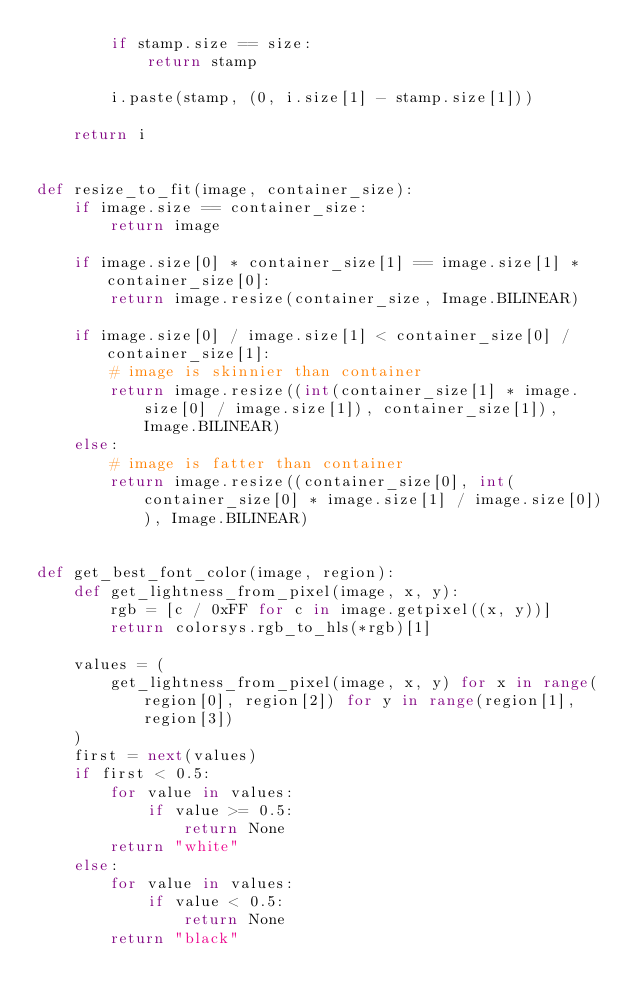Convert code to text. <code><loc_0><loc_0><loc_500><loc_500><_Python_>        if stamp.size == size:
            return stamp

        i.paste(stamp, (0, i.size[1] - stamp.size[1]))

    return i


def resize_to_fit(image, container_size):
    if image.size == container_size:
        return image

    if image.size[0] * container_size[1] == image.size[1] * container_size[0]:
        return image.resize(container_size, Image.BILINEAR)

    if image.size[0] / image.size[1] < container_size[0] / container_size[1]:
        # image is skinnier than container
        return image.resize((int(container_size[1] * image.size[0] / image.size[1]), container_size[1]), Image.BILINEAR)
    else:
        # image is fatter than container
        return image.resize((container_size[0], int(container_size[0] * image.size[1] / image.size[0])), Image.BILINEAR)


def get_best_font_color(image, region):
    def get_lightness_from_pixel(image, x, y):
        rgb = [c / 0xFF for c in image.getpixel((x, y))]
        return colorsys.rgb_to_hls(*rgb)[1]

    values = (
        get_lightness_from_pixel(image, x, y) for x in range(region[0], region[2]) for y in range(region[1], region[3])
    )
    first = next(values)
    if first < 0.5:
        for value in values:
            if value >= 0.5:
                return None
        return "white"
    else:
        for value in values:
            if value < 0.5:
                return None
        return "black"
</code> 